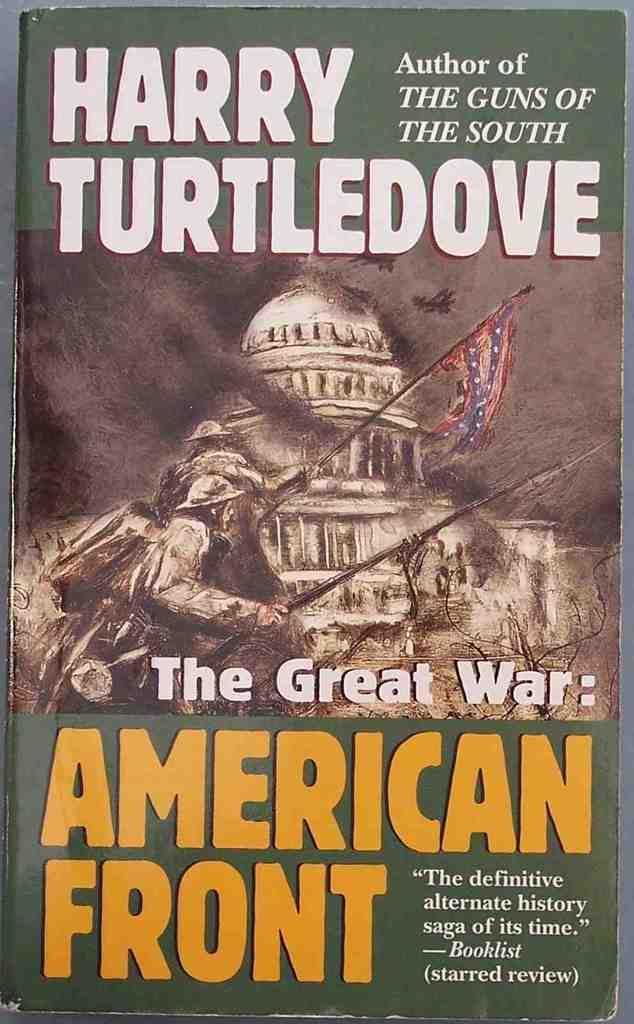<image>
Give a short and clear explanation of the subsequent image. The cover of a book by Harry Turtledove features the title "The Great War: American Front." 